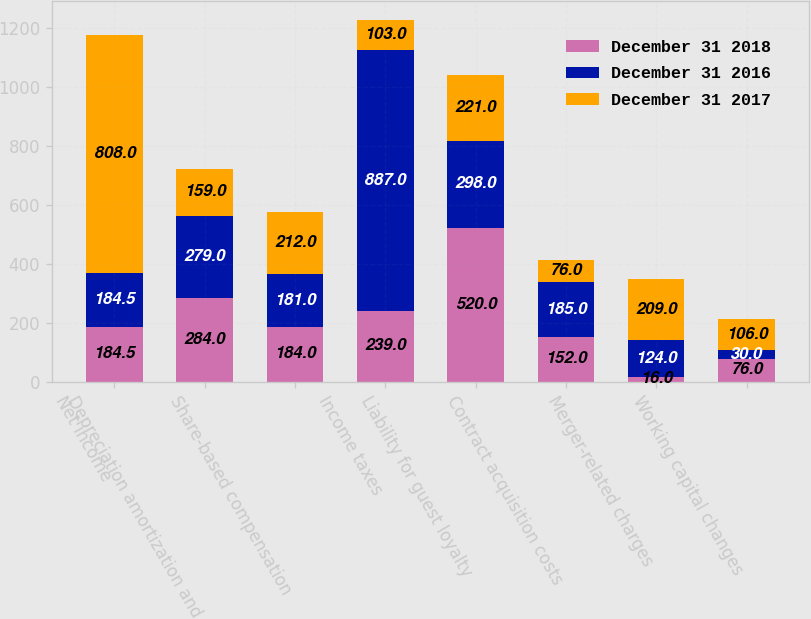<chart> <loc_0><loc_0><loc_500><loc_500><stacked_bar_chart><ecel><fcel>Net income<fcel>Depreciation amortization and<fcel>Share-based compensation<fcel>Income taxes<fcel>Liability for guest loyalty<fcel>Contract acquisition costs<fcel>Merger-related charges<fcel>Working capital changes<nl><fcel>December 31 2018<fcel>184.5<fcel>284<fcel>184<fcel>239<fcel>520<fcel>152<fcel>16<fcel>76<nl><fcel>December 31 2016<fcel>184.5<fcel>279<fcel>181<fcel>887<fcel>298<fcel>185<fcel>124<fcel>30<nl><fcel>December 31 2017<fcel>808<fcel>159<fcel>212<fcel>103<fcel>221<fcel>76<fcel>209<fcel>106<nl></chart> 